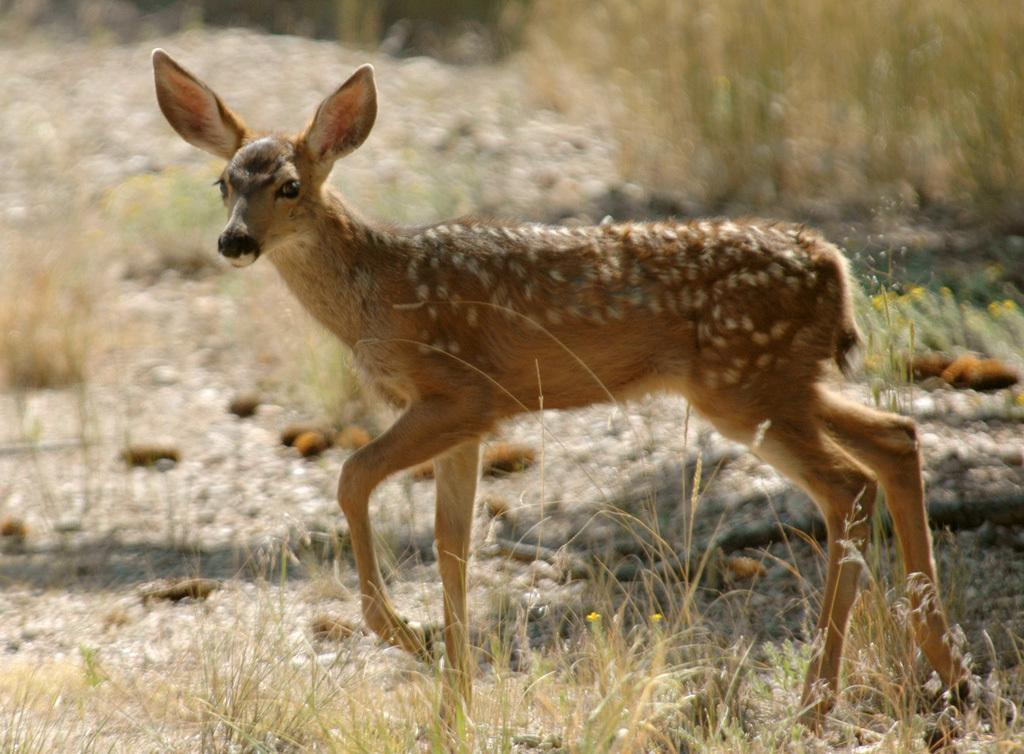What animal is in the center of the image? There is a deer in the center of the image. What type of vegetation is at the bottom of the image? There is grass and stones at the bottom of the image. What can be seen in the background of the image? There are plants, flowers, and additional stones in the background of the image. What type of elbow can be seen in the image? There is no elbow present in the image. What type of stew is being prepared in the background of the image? There is no stew or cooking activity depicted in the image. 